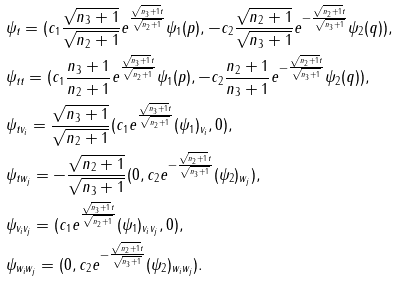Convert formula to latex. <formula><loc_0><loc_0><loc_500><loc_500>& \psi _ { t } = ( c _ { 1 } \frac { \sqrt { n _ { 3 } + 1 } } { \sqrt { n _ { 2 } + 1 } } e ^ { \frac { \sqrt { n _ { 3 } + 1 } t } { \sqrt { n _ { 2 } + 1 } } } \psi _ { 1 } ( p ) , - c _ { 2 } \frac { \sqrt { n _ { 2 } + 1 } } { \sqrt { n _ { 3 } + 1 } } e ^ { - \frac { \sqrt { n _ { 2 } + 1 } t } { \sqrt { n _ { 3 } + 1 } } } \psi _ { 2 } ( q ) ) , \\ & \psi _ { t t } = ( c _ { 1 } \frac { n _ { 3 } + 1 } { n _ { 2 } + 1 } e ^ { \frac { \sqrt { n _ { 3 } + 1 } t } { \sqrt { n _ { 2 } + 1 } } } \psi _ { 1 } ( p ) , - c _ { 2 } \frac { n _ { 2 } + 1 } { n _ { 3 } + 1 } e ^ { - \frac { \sqrt { n _ { 2 } + 1 } t } { \sqrt { n _ { 3 } + 1 } } } \psi _ { 2 } ( q ) ) , \\ & \psi _ { t v _ { i } } = \frac { \sqrt { n _ { 3 } + 1 } } { \sqrt { n _ { 2 } + 1 } } ( c _ { 1 } e ^ { \frac { \sqrt { n _ { 3 } + 1 } t } { \sqrt { n _ { 2 } + 1 } } } ( \psi _ { 1 } ) _ { v _ { i } } , 0 ) , \\ & \psi _ { t w _ { j } } = - \frac { \sqrt { n _ { 2 } + 1 } } { \sqrt { n _ { 3 } + 1 } } ( 0 , c _ { 2 } e ^ { - \frac { \sqrt { n _ { 2 } + 1 } t } { \sqrt { n _ { 3 } + 1 } } } ( \psi _ { 2 } ) _ { w _ { j } } ) , \\ & \psi _ { v _ { i } v _ { j } } = ( c _ { 1 } e ^ { \frac { \sqrt { n _ { 3 } + 1 } t } { \sqrt { n _ { 2 } + 1 } } } ( \psi _ { 1 } ) _ { v _ { i } v _ { j } } , 0 ) , \\ & \psi _ { w _ { i } w _ { j } } = ( 0 , c _ { 2 } e ^ { - \frac { \sqrt { n _ { 2 } + 1 } t } { \sqrt { n _ { 3 } + 1 } } } ( \psi _ { 2 } ) _ { w _ { i } w _ { j } } ) .</formula> 